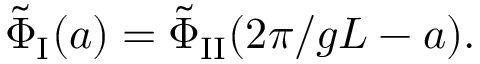<formula> <loc_0><loc_0><loc_500><loc_500>\tilde { \Phi } _ { I } ( a ) = \tilde { \Phi } _ { I I } ( 2 \pi / g L - a ) .</formula> 